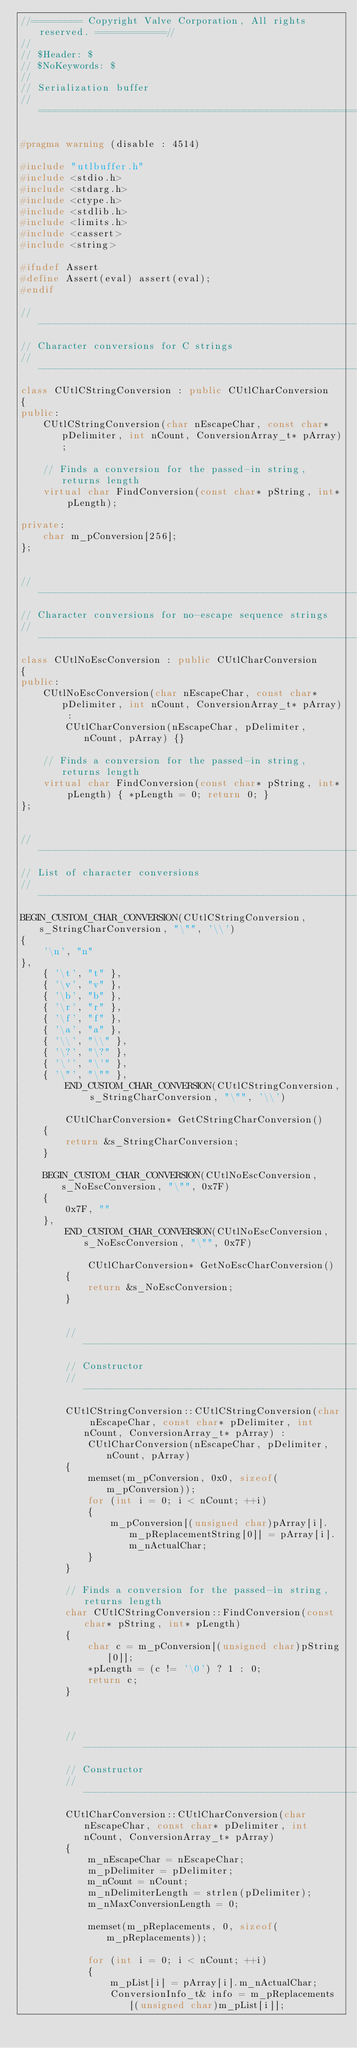Convert code to text. <code><loc_0><loc_0><loc_500><loc_500><_C++_>//========= Copyright Valve Corporation, All rights reserved. ============//
//
// $Header: $
// $NoKeywords: $
//
// Serialization buffer
//===========================================================================//

#pragma warning (disable : 4514)

#include "utlbuffer.h"
#include <stdio.h>
#include <stdarg.h>
#include <ctype.h>
#include <stdlib.h>
#include <limits.h>
#include <cassert>
#include <string>

#ifndef Assert
#define Assert(eval) assert(eval);
#endif

//-----------------------------------------------------------------------------
// Character conversions for C strings
//-----------------------------------------------------------------------------
class CUtlCStringConversion : public CUtlCharConversion
{
public:
	CUtlCStringConversion(char nEscapeChar, const char* pDelimiter, int nCount, ConversionArray_t* pArray);

	// Finds a conversion for the passed-in string, returns length
	virtual char FindConversion(const char* pString, int* pLength);

private:
	char m_pConversion[256];
};


//-----------------------------------------------------------------------------
// Character conversions for no-escape sequence strings
//-----------------------------------------------------------------------------
class CUtlNoEscConversion : public CUtlCharConversion
{
public:
	CUtlNoEscConversion(char nEscapeChar, const char* pDelimiter, int nCount, ConversionArray_t* pArray) :
		CUtlCharConversion(nEscapeChar, pDelimiter, nCount, pArray) {}

	// Finds a conversion for the passed-in string, returns length
	virtual char FindConversion(const char* pString, int* pLength) { *pLength = 0; return 0; }
};


//-----------------------------------------------------------------------------
// List of character conversions
//-----------------------------------------------------------------------------
BEGIN_CUSTOM_CHAR_CONVERSION(CUtlCStringConversion, s_StringCharConversion, "\"", '\\')
{
	'\n', "n"
},
	{ '\t', "t" },
	{ '\v', "v" },
	{ '\b', "b" },
	{ '\r', "r" },
	{ '\f', "f" },
	{ '\a', "a" },
	{ '\\', "\\" },
	{ '\?', "\?" },
	{ '\'', "\'" },
	{ '\"', "\"" },
		END_CUSTOM_CHAR_CONVERSION(CUtlCStringConversion, s_StringCharConversion, "\"", '\\')

		CUtlCharConversion* GetCStringCharConversion()
	{
		return &s_StringCharConversion;
	}

	BEGIN_CUSTOM_CHAR_CONVERSION(CUtlNoEscConversion, s_NoEscConversion, "\"", 0x7F)
	{
		0x7F, ""
	},
		END_CUSTOM_CHAR_CONVERSION(CUtlNoEscConversion, s_NoEscConversion, "\"", 0x7F)

			CUtlCharConversion* GetNoEscCharConversion()
		{
			return &s_NoEscConversion;
		}


		//-----------------------------------------------------------------------------
		// Constructor
		//-----------------------------------------------------------------------------
		CUtlCStringConversion::CUtlCStringConversion(char nEscapeChar, const char* pDelimiter, int nCount, ConversionArray_t* pArray) :
			CUtlCharConversion(nEscapeChar, pDelimiter, nCount, pArray)
		{
			memset(m_pConversion, 0x0, sizeof(m_pConversion));
			for (int i = 0; i < nCount; ++i)
			{
				m_pConversion[(unsigned char)pArray[i].m_pReplacementString[0]] = pArray[i].m_nActualChar;
			}
		}

		// Finds a conversion for the passed-in string, returns length
		char CUtlCStringConversion::FindConversion(const char* pString, int* pLength)
		{
			char c = m_pConversion[(unsigned char)pString[0]];
			*pLength = (c != '\0') ? 1 : 0;
			return c;
		}



		//-----------------------------------------------------------------------------
		// Constructor
		//-----------------------------------------------------------------------------
		CUtlCharConversion::CUtlCharConversion(char nEscapeChar, const char* pDelimiter, int nCount, ConversionArray_t* pArray)
		{
			m_nEscapeChar = nEscapeChar;
			m_pDelimiter = pDelimiter;
			m_nCount = nCount;
			m_nDelimiterLength = strlen(pDelimiter);
			m_nMaxConversionLength = 0;

			memset(m_pReplacements, 0, sizeof(m_pReplacements));

			for (int i = 0; i < nCount; ++i)
			{
				m_pList[i] = pArray[i].m_nActualChar;
				ConversionInfo_t& info = m_pReplacements[(unsigned char)m_pList[i]];
</code> 